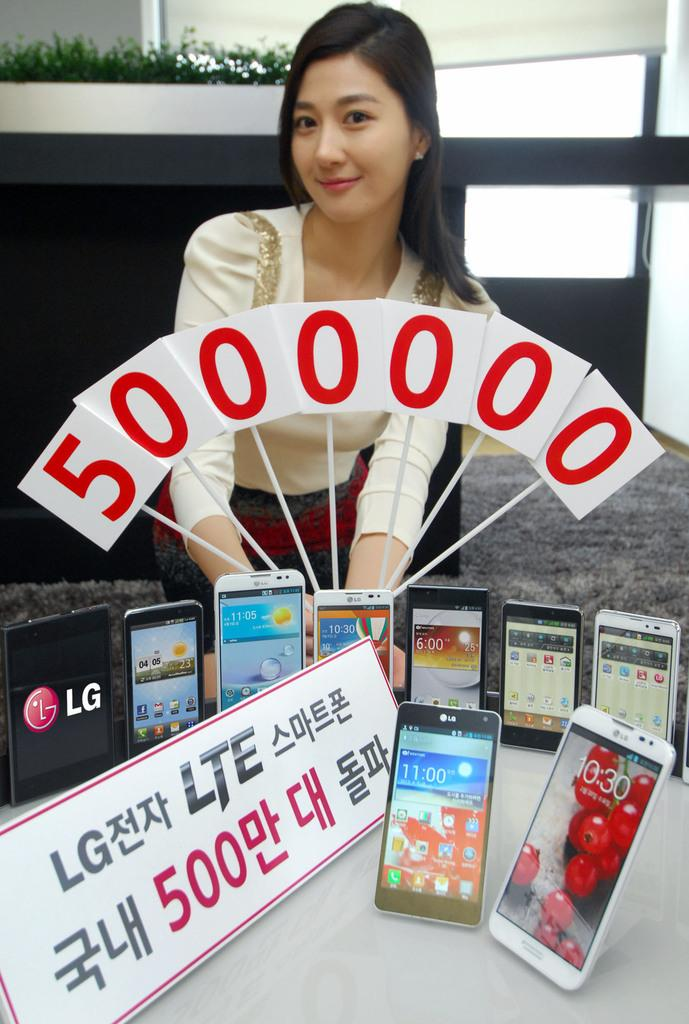<image>
Summarize the visual content of the image. Woman standing in front of some phones and a sign that says 500 onit. 